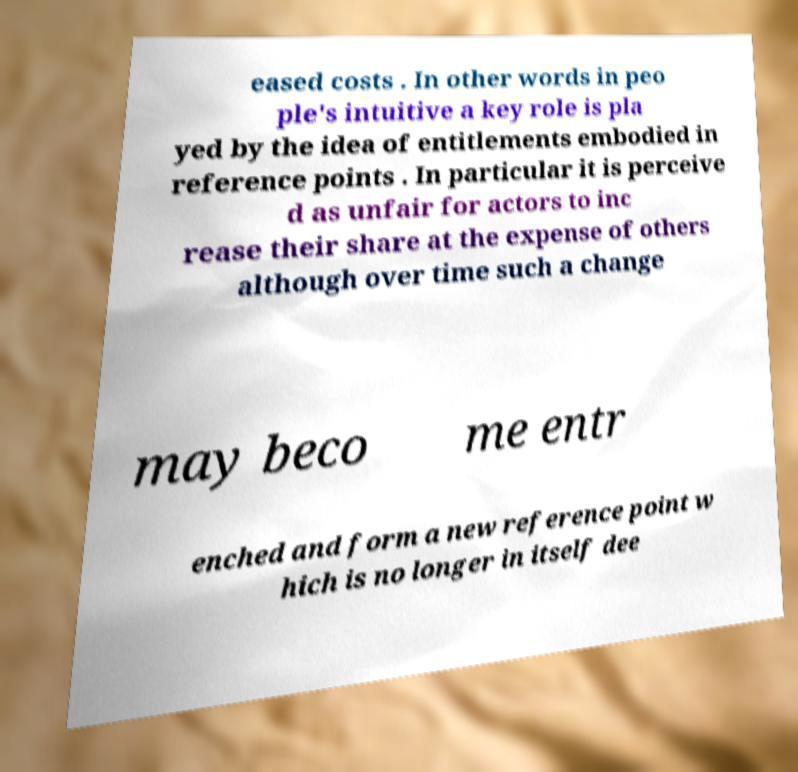For documentation purposes, I need the text within this image transcribed. Could you provide that? eased costs . In other words in peo ple's intuitive a key role is pla yed by the idea of entitlements embodied in reference points . In particular it is perceive d as unfair for actors to inc rease their share at the expense of others although over time such a change may beco me entr enched and form a new reference point w hich is no longer in itself dee 